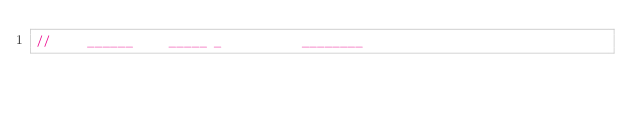Convert code to text. <code><loc_0><loc_0><loc_500><loc_500><_C++_>//     ______     _____ _           ________</code> 